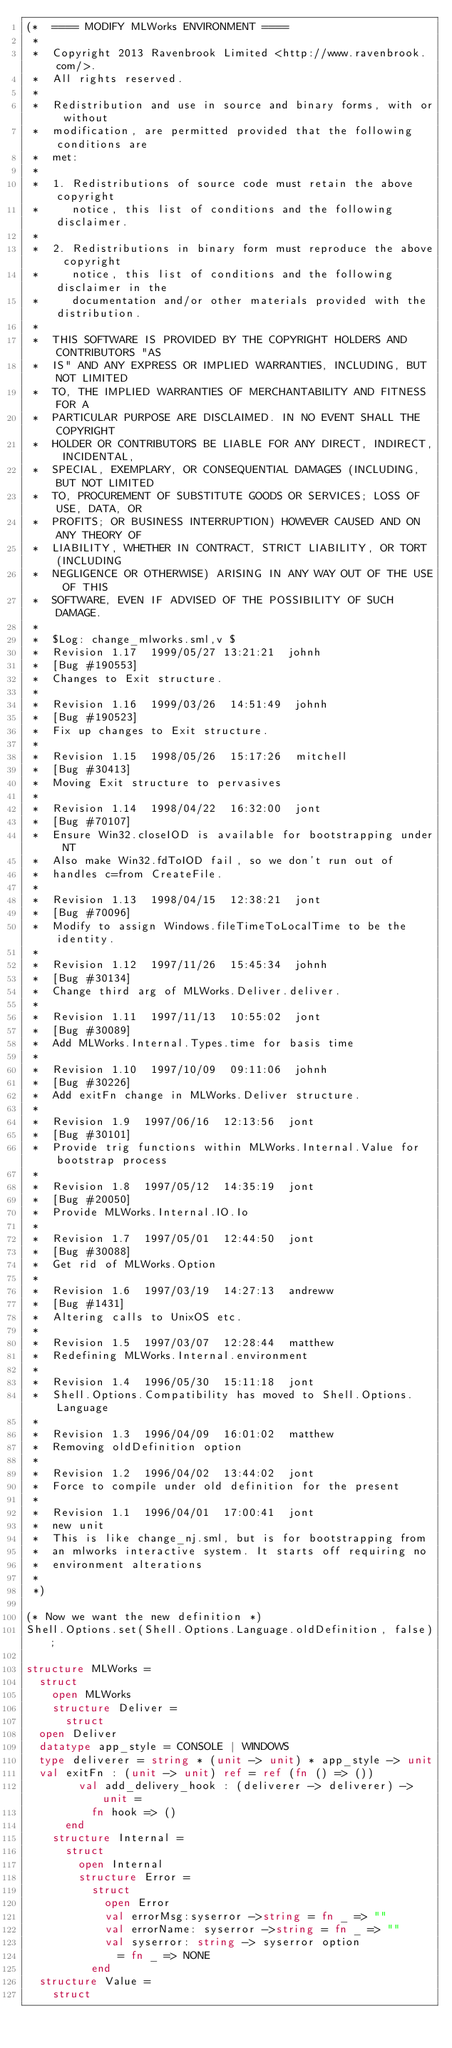Convert code to text. <code><loc_0><loc_0><loc_500><loc_500><_SML_>(*  ==== MODIFY MLWorks ENVIRONMENT ====
 *
 *  Copyright 2013 Ravenbrook Limited <http://www.ravenbrook.com/>.
 *  All rights reserved.
 *  
 *  Redistribution and use in source and binary forms, with or without
 *  modification, are permitted provided that the following conditions are
 *  met:
 *  
 *  1. Redistributions of source code must retain the above copyright
 *     notice, this list of conditions and the following disclaimer.
 *  
 *  2. Redistributions in binary form must reproduce the above copyright
 *     notice, this list of conditions and the following disclaimer in the
 *     documentation and/or other materials provided with the distribution.
 *  
 *  THIS SOFTWARE IS PROVIDED BY THE COPYRIGHT HOLDERS AND CONTRIBUTORS "AS
 *  IS" AND ANY EXPRESS OR IMPLIED WARRANTIES, INCLUDING, BUT NOT LIMITED
 *  TO, THE IMPLIED WARRANTIES OF MERCHANTABILITY AND FITNESS FOR A
 *  PARTICULAR PURPOSE ARE DISCLAIMED. IN NO EVENT SHALL THE COPYRIGHT
 *  HOLDER OR CONTRIBUTORS BE LIABLE FOR ANY DIRECT, INDIRECT, INCIDENTAL,
 *  SPECIAL, EXEMPLARY, OR CONSEQUENTIAL DAMAGES (INCLUDING, BUT NOT LIMITED
 *  TO, PROCUREMENT OF SUBSTITUTE GOODS OR SERVICES; LOSS OF USE, DATA, OR
 *  PROFITS; OR BUSINESS INTERRUPTION) HOWEVER CAUSED AND ON ANY THEORY OF
 *  LIABILITY, WHETHER IN CONTRACT, STRICT LIABILITY, OR TORT (INCLUDING
 *  NEGLIGENCE OR OTHERWISE) ARISING IN ANY WAY OUT OF THE USE OF THIS
 *  SOFTWARE, EVEN IF ADVISED OF THE POSSIBILITY OF SUCH DAMAGE.
 *
 *  $Log: change_mlworks.sml,v $
 *  Revision 1.17  1999/05/27 13:21:21  johnh
 *  [Bug #190553]
 *  Changes to Exit structure.
 *
 *  Revision 1.16  1999/03/26  14:51:49  johnh
 *  [Bug #190523]
 *  Fix up changes to Exit structure.
 *
 *  Revision 1.15  1998/05/26  15:17:26  mitchell
 *  [Bug #30413]
 *  Moving Exit structure to pervasives
 *
 *  Revision 1.14  1998/04/22  16:32:00  jont
 *  [Bug #70107]
 *  Ensure Win32.closeIOD is available for bootstrapping under NT
 *  Also make Win32.fdToIOD fail, so we don't run out of
 *  handles c=from CreateFile.
 *
 *  Revision 1.13  1998/04/15  12:38:21  jont
 *  [Bug #70096]
 *  Modify to assign Windows.fileTimeToLocalTime to be the identity.
 *
 *  Revision 1.12  1997/11/26  15:45:34  johnh
 *  [Bug #30134]
 *  Change third arg of MLWorks.Deliver.deliver.
 *
 *  Revision 1.11  1997/11/13  10:55:02  jont
 *  [Bug #30089]
 *  Add MLWorks.Internal.Types.time for basis time
 *
 *  Revision 1.10  1997/10/09  09:11:06  johnh
 *  [Bug #30226]
 *  Add exitFn change in MLWorks.Deliver structure.
 *
 *  Revision 1.9  1997/06/16  12:13:56  jont
 *  [Bug #30101]
 *  Provide trig functions within MLWorks.Internal.Value for bootstrap process
 *
 *  Revision 1.8  1997/05/12  14:35:19  jont
 *  [Bug #20050]
 *  Provide MLWorks.Internal.IO.Io
 *
 *  Revision 1.7  1997/05/01  12:44:50  jont
 *  [Bug #30088]
 *  Get rid of MLWorks.Option
 *
 *  Revision 1.6  1997/03/19  14:27:13  andreww
 *  [Bug #1431]
 *  Altering calls to UnixOS etc.
 *
 *  Revision 1.5  1997/03/07  12:28:44  matthew
 *  Redefining MLWorks.Internal.environment
 *
 *  Revision 1.4  1996/05/30  15:11:18  jont
 *  Shell.Options.Compatibility has moved to Shell.Options.Language
 *
 *  Revision 1.3  1996/04/09  16:01:02  matthew
 *  Removing oldDefinition option
 *
 *  Revision 1.2  1996/04/02  13:44:02  jont
 *  Force to compile under old definition for the present
 *
 *  Revision 1.1  1996/04/01  17:00:41  jont
 *  new unit
 *  This is like change_nj.sml, but is for bootstrapping from
 *  an mlworks interactive system. It starts off requiring no
 *  environment alterations
 *
 *)

(* Now we want the new definition *)
Shell.Options.set(Shell.Options.Language.oldDefinition, false);

structure MLWorks =
  struct
    open MLWorks
    structure Deliver = 
      struct
	open Deliver
	datatype app_style = CONSOLE | WINDOWS
	type deliverer = string * (unit -> unit) * app_style -> unit
	val exitFn : (unit -> unit) ref = ref (fn () => ())
        val add_delivery_hook : (deliverer -> deliverer) -> unit =
          fn hook => ()
      end
    structure Internal = 
      struct
        open Internal
        structure Error =
          struct
            open Error
            val errorMsg:syserror ->string = fn _ => ""
            val errorName: syserror ->string = fn _ => ""
            val syserror: string -> syserror option 
              = fn _ => NONE
          end
	structure Value =
	  struct</code> 